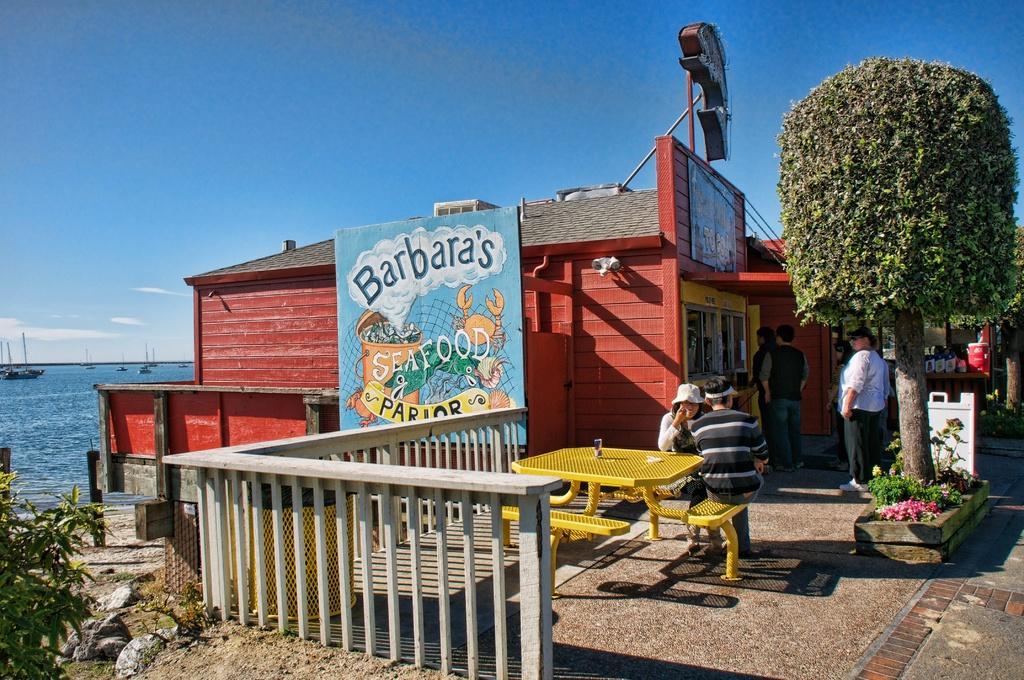Please provide a concise description of this image. In this image there is a shed and we can see boards. There are trees. We can see a table and benches. In the background there is water and we can see boats on the water. At the top there is sky and we can see shrubs. There are people. 